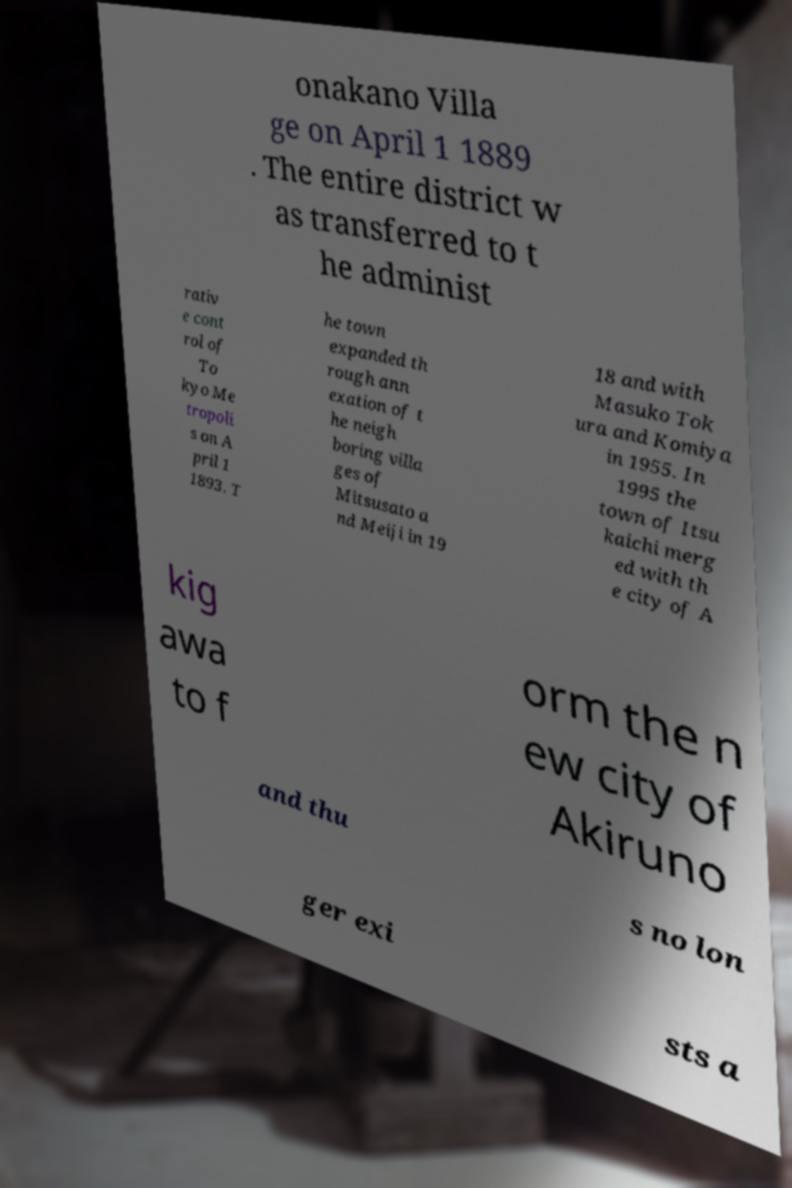Please read and relay the text visible in this image. What does it say? onakano Villa ge on April 1 1889 . The entire district w as transferred to t he administ rativ e cont rol of To kyo Me tropoli s on A pril 1 1893. T he town expanded th rough ann exation of t he neigh boring villa ges of Mitsusato a nd Meiji in 19 18 and with Masuko Tok ura and Komiya in 1955. In 1995 the town of Itsu kaichi merg ed with th e city of A kig awa to f orm the n ew city of Akiruno and thu s no lon ger exi sts a 